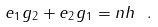<formula> <loc_0><loc_0><loc_500><loc_500>e _ { 1 } g _ { 2 } + e _ { 2 } g _ { 1 } = n h \ .</formula> 